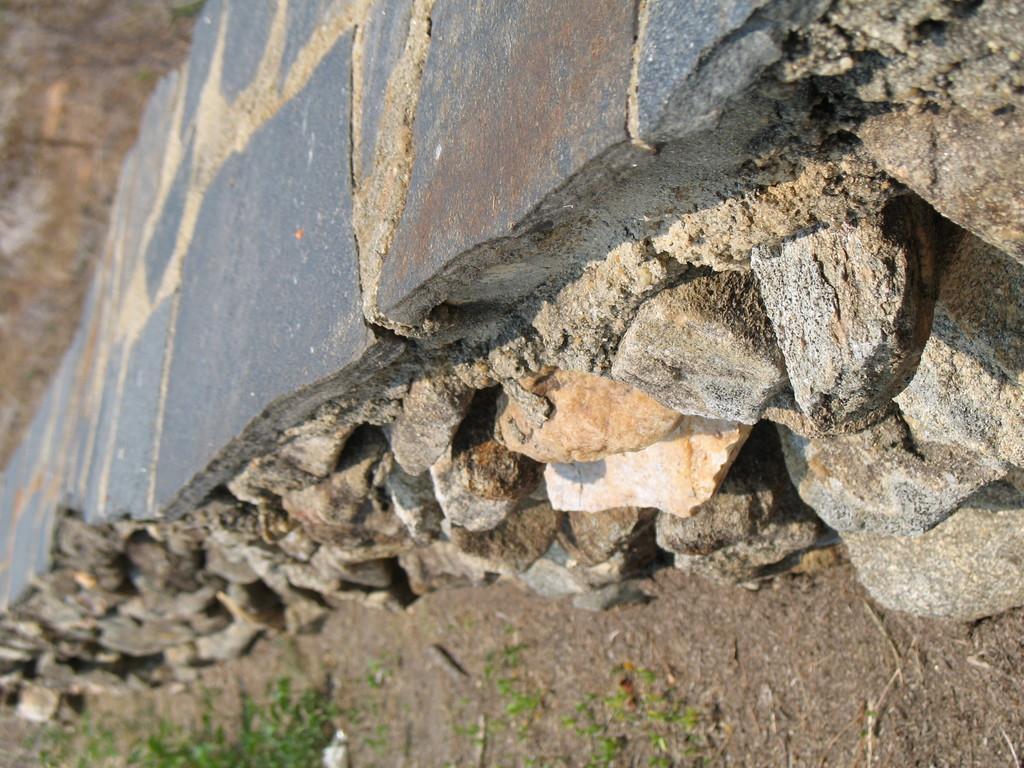Describe this image in one or two sentences. In this image in the foreground there is a wall and some rocks, at the bottom there is grass and some sand. 